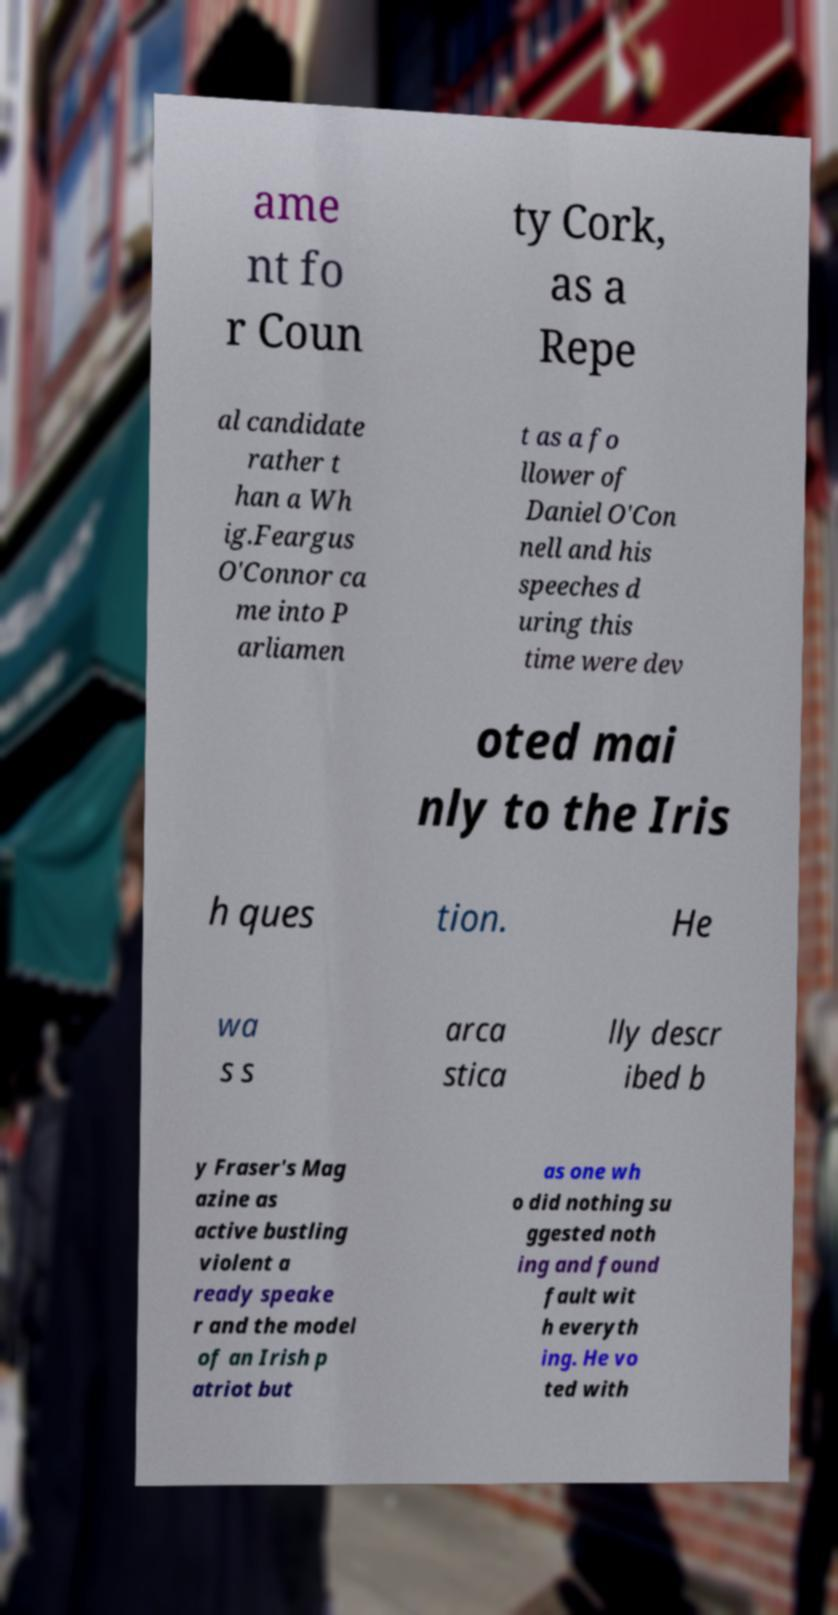Can you read and provide the text displayed in the image?This photo seems to have some interesting text. Can you extract and type it out for me? ame nt fo r Coun ty Cork, as a Repe al candidate rather t han a Wh ig.Feargus O'Connor ca me into P arliamen t as a fo llower of Daniel O'Con nell and his speeches d uring this time were dev oted mai nly to the Iris h ques tion. He wa s s arca stica lly descr ibed b y Fraser's Mag azine as active bustling violent a ready speake r and the model of an Irish p atriot but as one wh o did nothing su ggested noth ing and found fault wit h everyth ing. He vo ted with 